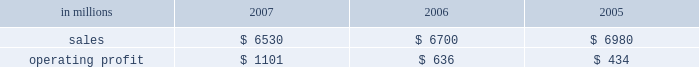Customer demand .
This compared with 555000 tons of total downtime in 2006 of which 150000 tons related to lack-of-orders .
Printing papers in millions 2007 2006 2005 .
North american printing papers net sales in 2007 were $ 3.5 billion compared with $ 4.4 billion in 2006 ( $ 3.5 billion excluding the coated and super- calendered papers business ) and $ 4.8 billion in 2005 ( $ 3.2 billion excluding the coated and super- calendered papers business ) .
Sales volumes decreased in 2007 versus 2006 partially due to reduced production capacity resulting from the conversion of the paper machine at the pensacola mill to the production of lightweight linerboard for our industrial packaging segment .
Average sales price realizations increased significantly , reflecting benefits from price increases announced throughout 2007 .
Lack-of-order downtime declined to 27000 tons in 2007 from 40000 tons in 2006 .
Operating earnings of $ 537 million in 2007 increased from $ 482 million in 2006 ( $ 407 million excluding the coated and supercalendered papers business ) and $ 175 million in 2005 ( $ 74 million excluding the coated and supercalendered papers business ) .
The benefits from improved average sales price realizations more than offset the effects of higher input costs for wood , energy , and freight .
Mill operations were favorable compared with the prior year due to current-year improvements in machine performance and energy conservation efforts .
Sales volumes for the first quarter of 2008 are expected to increase slightly , and the mix of prod- ucts sold to improve .
Demand for printing papers in north america was steady as the quarter began .
Price increases for cut-size paper and roll stock have been announced that are expected to be effective principally late in the first quarter .
Planned mill maintenance outage costs should be about the same as in the fourth quarter ; however , raw material costs are expected to continue to increase , primarily for wood and energy .
Brazil ian papers net sales for 2007 of $ 850 mil- lion were higher than the $ 495 million in 2006 and the $ 465 million in 2005 .
Compared with 2006 , aver- age sales price realizations improved reflecting price increases for uncoated freesheet paper realized dur- ing the second half of 2006 and the first half of 2007 .
Excluding the impact of the luiz antonio acquisition , sales volumes increased primarily for cut size and offset paper .
Operating profits for 2007 of $ 246 mil- lion were up from $ 122 million in 2006 and $ 134 mil- lion in 2005 as the benefits from higher sales prices and favorable manufacturing costs were only parti- ally offset by higher input costs .
Contributions from the luiz antonio acquisition increased net sales by approximately $ 350 million and earnings by approx- imately $ 80 million in 2007 .
Entering 2008 , sales volumes for uncoated freesheet paper and pulp should be seasonally lower .
Average price realizations should be essentially flat , but mar- gins are expected to reflect a less favorable product mix .
Energy costs , primarily for hydroelectric power , are expected to increase significantly reflecting a lack of rainfall in brazil in the latter part of 2007 .
European papers net sales in 2007 were $ 1.5 bil- lion compared with $ 1.3 billion in 2006 and $ 1.2 bil- lion in 2005 .
Sales volumes in 2007 were higher than in 2006 at our eastern european mills reflecting stronger market demand and improved efficiencies , but lower in western europe reflecting the closure of the marasquel mill in 2006 .
Average sales price real- izations increased significantly in 2007 in both east- ern and western european markets .
Operating profits of $ 214 million in 2007 increased from a loss of $ 16 million in 2006 and earnings of $ 88 million in 2005 .
The loss in 2006 reflects the impact of a $ 128 million impairment charge to reduce the carrying value of the fixed assets at the saillat , france mill .
Excluding this charge , the improvement in 2007 compared with 2006 reflects the contribution from higher net sales , partially offset by higher input costs for wood , energy and freight .
Looking ahead to the first quarter of 2008 , sales volumes are expected to be stable in western europe , but seasonally weaker in eastern europe and russia .
Average price realizations are expected to remain about flat .
Wood costs are expected to increase , especially in russia due to strong demand ahead of tariff increases , and energy costs are anticipated to be seasonally higher .
Asian printing papers net sales were approx- imately $ 20 million in 2007 , compared with $ 15 mil- lion in 2006 and $ 10 million in 2005 .
Operating earnings increased slightly in 2007 , but were close to breakeven in all periods .
U.s .
Market pulp sales in 2007 totaled $ 655 mil- lion compared with $ 510 million and $ 525 million in 2006 and 2005 , respectively .
Sales volumes in 2007 were up from 2006 levels , primarily for paper and .
What was the profit margin from printing paper in 2006? 
Computations: (636 / 6700)
Answer: 0.09493. 